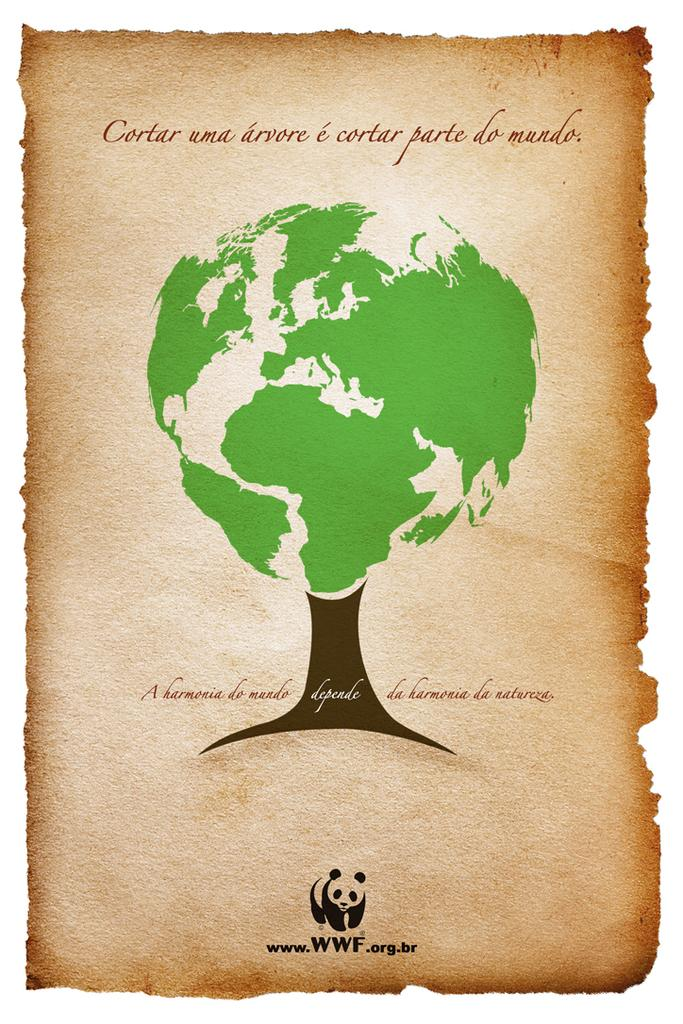What type of visual is the image? The image is a poster. What can be found on the poster besides the visual elements? There is text or writing on the poster. What type of natural element is visible in the image? There is a tree visible in the image. Where is the logo located on the poster? There is a logo at the bottom of the image. What color of paint is being used to create the arch in the image? There is no arch present in the image, so the color of paint cannot be determined. 